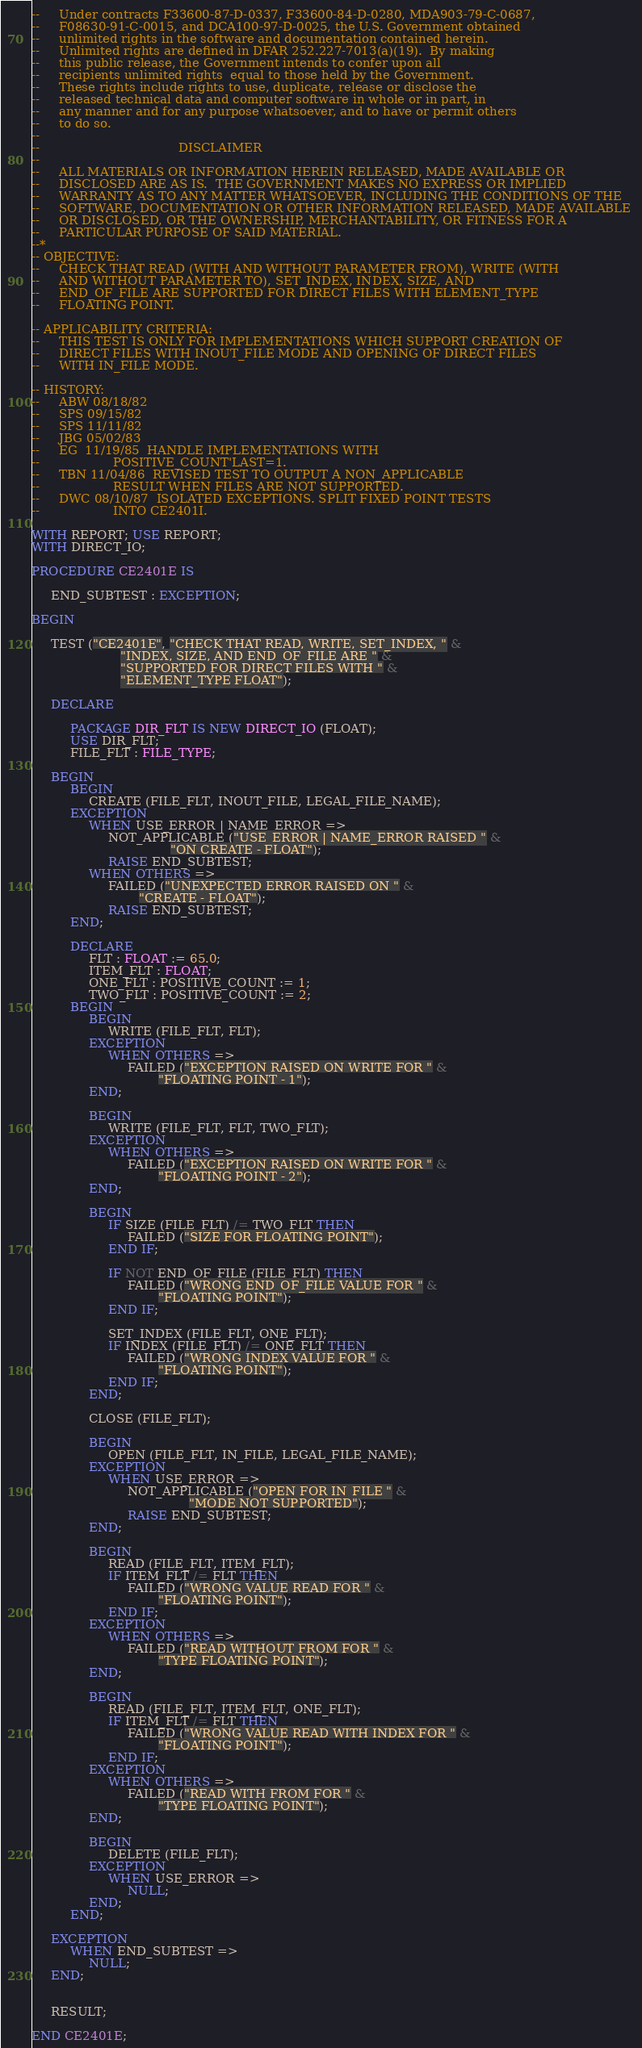Convert code to text. <code><loc_0><loc_0><loc_500><loc_500><_Ada_>--     Under contracts F33600-87-D-0337, F33600-84-D-0280, MDA903-79-C-0687,
--     F08630-91-C-0015, and DCA100-97-D-0025, the U.S. Government obtained 
--     unlimited rights in the software and documentation contained herein.
--     Unlimited rights are defined in DFAR 252.227-7013(a)(19).  By making 
--     this public release, the Government intends to confer upon all 
--     recipients unlimited rights  equal to those held by the Government.  
--     These rights include rights to use, duplicate, release or disclose the 
--     released technical data and computer software in whole or in part, in 
--     any manner and for any purpose whatsoever, and to have or permit others 
--     to do so.
--
--                                    DISCLAIMER
--
--     ALL MATERIALS OR INFORMATION HEREIN RELEASED, MADE AVAILABLE OR
--     DISCLOSED ARE AS IS.  THE GOVERNMENT MAKES NO EXPRESS OR IMPLIED 
--     WARRANTY AS TO ANY MATTER WHATSOEVER, INCLUDING THE CONDITIONS OF THE
--     SOFTWARE, DOCUMENTATION OR OTHER INFORMATION RELEASED, MADE AVAILABLE 
--     OR DISCLOSED, OR THE OWNERSHIP, MERCHANTABILITY, OR FITNESS FOR A
--     PARTICULAR PURPOSE OF SAID MATERIAL.
--*
-- OBJECTIVE:
--     CHECK THAT READ (WITH AND WITHOUT PARAMETER FROM), WRITE (WITH
--     AND WITHOUT PARAMETER TO), SET_INDEX, INDEX, SIZE, AND
--     END_OF_FILE ARE SUPPORTED FOR DIRECT FILES WITH ELEMENT_TYPE
--     FLOATING POINT.

-- APPLICABILITY CRITERIA:
--     THIS TEST IS ONLY FOR IMPLEMENTATIONS WHICH SUPPORT CREATION OF
--     DIRECT FILES WITH INOUT_FILE MODE AND OPENING OF DIRECT FILES
--     WITH IN_FILE MODE.

-- HISTORY:
--     ABW 08/18/82
--     SPS 09/15/82
--     SPS 11/11/82
--     JBG 05/02/83
--     EG  11/19/85  HANDLE IMPLEMENTATIONS WITH
--                   POSITIVE_COUNT'LAST=1.
--     TBN 11/04/86  REVISED TEST TO OUTPUT A NON_APPLICABLE
--                   RESULT WHEN FILES ARE NOT SUPPORTED.
--     DWC 08/10/87  ISOLATED EXCEPTIONS. SPLIT FIXED POINT TESTS
--                   INTO CE2401I.

WITH REPORT; USE REPORT;
WITH DIRECT_IO;

PROCEDURE CE2401E IS

     END_SUBTEST : EXCEPTION;

BEGIN

     TEST ("CE2401E", "CHECK THAT READ, WRITE, SET_INDEX, " &
                       "INDEX, SIZE, AND END_OF_FILE ARE " &
                       "SUPPORTED FOR DIRECT FILES WITH " &
                       "ELEMENT_TYPE FLOAT");

     DECLARE

          PACKAGE DIR_FLT IS NEW DIRECT_IO (FLOAT);
          USE DIR_FLT;
          FILE_FLT : FILE_TYPE;

     BEGIN
          BEGIN
               CREATE (FILE_FLT, INOUT_FILE, LEGAL_FILE_NAME);
          EXCEPTION
               WHEN USE_ERROR | NAME_ERROR =>
                    NOT_APPLICABLE ("USE_ERROR | NAME_ERROR RAISED " &
                                    "ON CREATE - FLOAT");
                    RAISE END_SUBTEST;
               WHEN OTHERS =>
                    FAILED ("UNEXPECTED ERROR RAISED ON " &
                            "CREATE - FLOAT");
                    RAISE END_SUBTEST;
          END;

          DECLARE
               FLT : FLOAT := 65.0;
               ITEM_FLT : FLOAT;
               ONE_FLT : POSITIVE_COUNT := 1;
               TWO_FLT : POSITIVE_COUNT := 2;
          BEGIN
               BEGIN
                    WRITE (FILE_FLT, FLT);
               EXCEPTION
                    WHEN OTHERS =>
                         FAILED ("EXCEPTION RAISED ON WRITE FOR " &
                                 "FLOATING POINT - 1");
               END;

               BEGIN
                    WRITE (FILE_FLT, FLT, TWO_FLT);
               EXCEPTION
                    WHEN OTHERS =>
                         FAILED ("EXCEPTION RAISED ON WRITE FOR " &
                                 "FLOATING POINT - 2");
               END;

               BEGIN
                    IF SIZE (FILE_FLT) /= TWO_FLT THEN
                         FAILED ("SIZE FOR FLOATING POINT");
                    END IF;

                    IF NOT END_OF_FILE (FILE_FLT) THEN
                         FAILED ("WRONG END_OF_FILE VALUE FOR " &
                                 "FLOATING POINT");
                    END IF;

                    SET_INDEX (FILE_FLT, ONE_FLT);
                    IF INDEX (FILE_FLT) /= ONE_FLT THEN
                         FAILED ("WRONG INDEX VALUE FOR " &
                                 "FLOATING POINT");
                    END IF;
               END;

               CLOSE (FILE_FLT);

               BEGIN
                    OPEN (FILE_FLT, IN_FILE, LEGAL_FILE_NAME);
               EXCEPTION
                    WHEN USE_ERROR =>
                         NOT_APPLICABLE ("OPEN FOR IN_FILE " &
                                         "MODE NOT SUPPORTED");
                         RAISE END_SUBTEST;
               END;

               BEGIN
                    READ (FILE_FLT, ITEM_FLT);
                    IF ITEM_FLT /= FLT THEN
                         FAILED ("WRONG VALUE READ FOR " &
                                 "FLOATING POINT");
                    END IF;
               EXCEPTION
                    WHEN OTHERS =>
                         FAILED ("READ WITHOUT FROM FOR " &
                                 "TYPE FLOATING POINT");
               END;

               BEGIN
                    READ (FILE_FLT, ITEM_FLT, ONE_FLT);
                    IF ITEM_FLT /= FLT THEN
                         FAILED ("WRONG VALUE READ WITH INDEX FOR " &
                                 "FLOATING POINT");
                    END IF;
               EXCEPTION
                    WHEN OTHERS =>
                         FAILED ("READ WITH FROM FOR " &
                                 "TYPE FLOATING POINT");
               END;

               BEGIN
                    DELETE (FILE_FLT);
               EXCEPTION
                    WHEN USE_ERROR =>
                         NULL;
               END;
          END;

     EXCEPTION
          WHEN END_SUBTEST =>
               NULL;
     END;


     RESULT;

END CE2401E;
</code> 